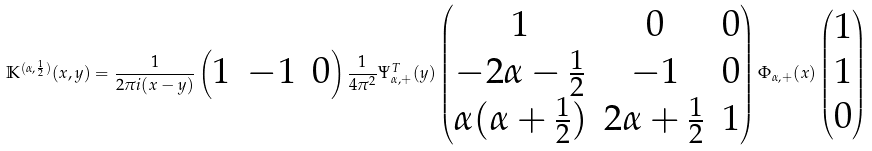<formula> <loc_0><loc_0><loc_500><loc_500>\mathbb { K } ^ { ( \alpha , \frac { 1 } { 2 } ) } ( x , y ) = \frac { 1 } { 2 \pi i ( x - y ) } \begin{pmatrix} 1 & - 1 & 0 \end{pmatrix} \frac { 1 } { 4 \pi ^ { 2 } } \Psi _ { \alpha , + } ^ { T } ( y ) \begin{pmatrix} 1 & 0 & 0 \\ - 2 \alpha - \frac { 1 } { 2 } & - 1 & 0 \\ \alpha ( \alpha + \frac { 1 } { 2 } ) & 2 \alpha + \frac { 1 } { 2 } & 1 \end{pmatrix} \Phi _ { \alpha , + } ( x ) \begin{pmatrix} 1 \\ 1 \\ 0 \end{pmatrix}</formula> 